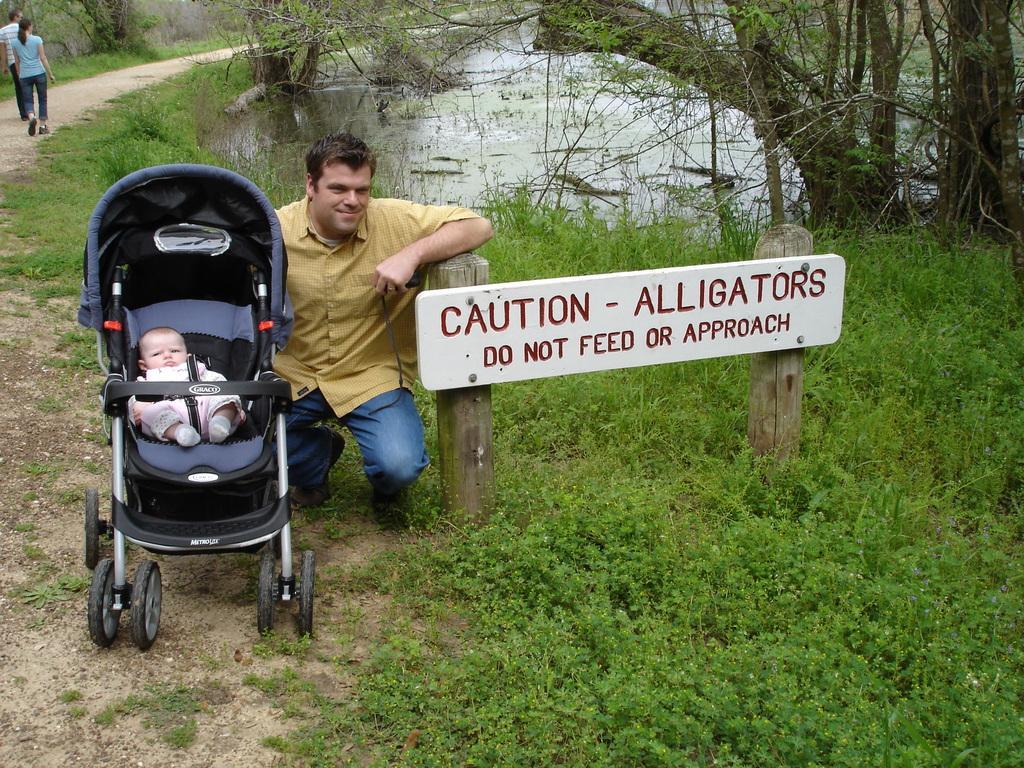Could you give a brief overview of what you see in this image? Here in this picture we can see a person in squat position present on the ground, which is fully covered with grass and plants over there and beside him we can see a baby stroller present with baby in it and on the right side we can see a board present and behind him we can see a couple walking on the road and we can see water present on the right side and we can see plants and trees present all over there. 